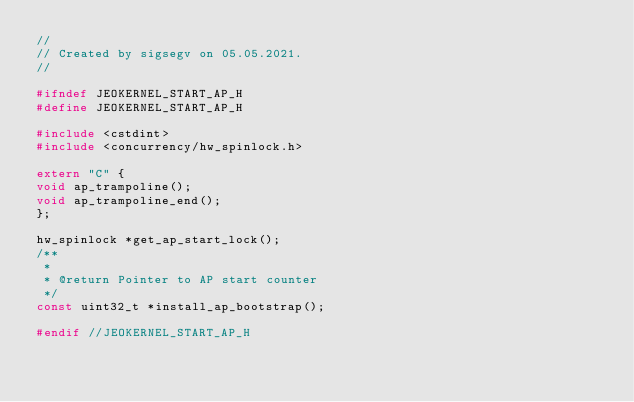Convert code to text. <code><loc_0><loc_0><loc_500><loc_500><_C_>//
// Created by sigsegv on 05.05.2021.
//

#ifndef JEOKERNEL_START_AP_H
#define JEOKERNEL_START_AP_H

#include <cstdint>
#include <concurrency/hw_spinlock.h>

extern "C" {
void ap_trampoline();
void ap_trampoline_end();
};

hw_spinlock *get_ap_start_lock();
/**
 *
 * @return Pointer to AP start counter
 */
const uint32_t *install_ap_bootstrap();

#endif //JEOKERNEL_START_AP_H
</code> 